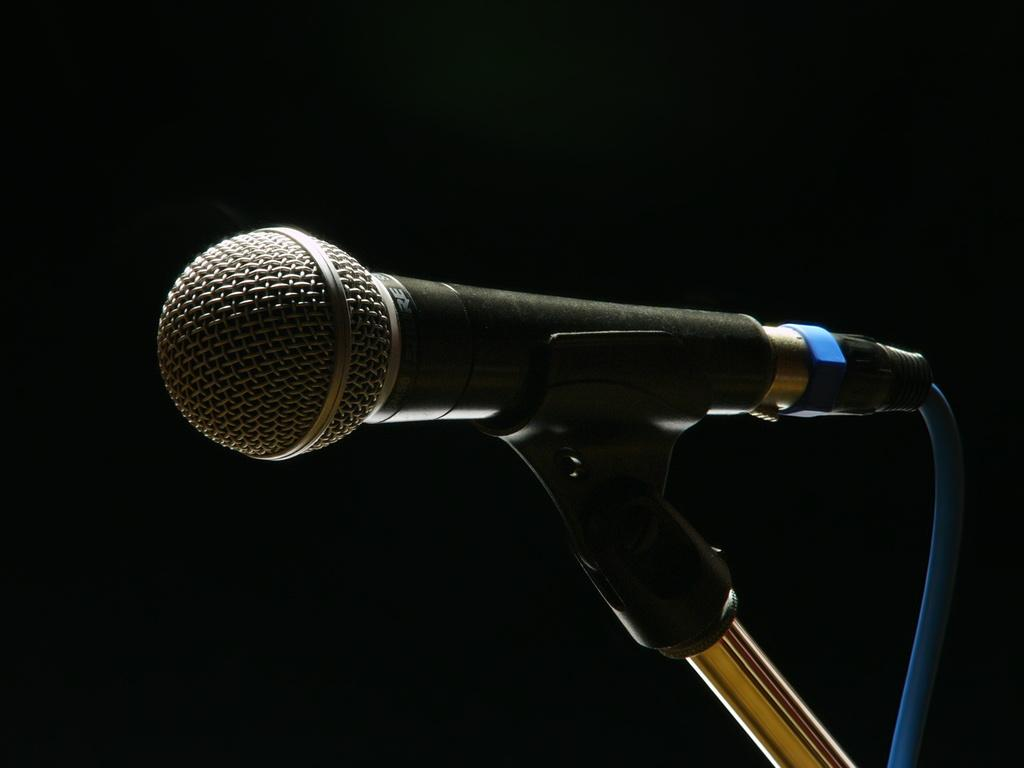What object is the main subject of the image? There is a microphone in the image. What feature does the microphone have? The microphone has a stand. What color is the background of the image? The background of the image is black. How does the fog affect the microphone in the image? There is no fog present in the image, so it does not affect the microphone. What type of dust can be seen on the microphone in the image? There is no dust present on the microphone in the image. 